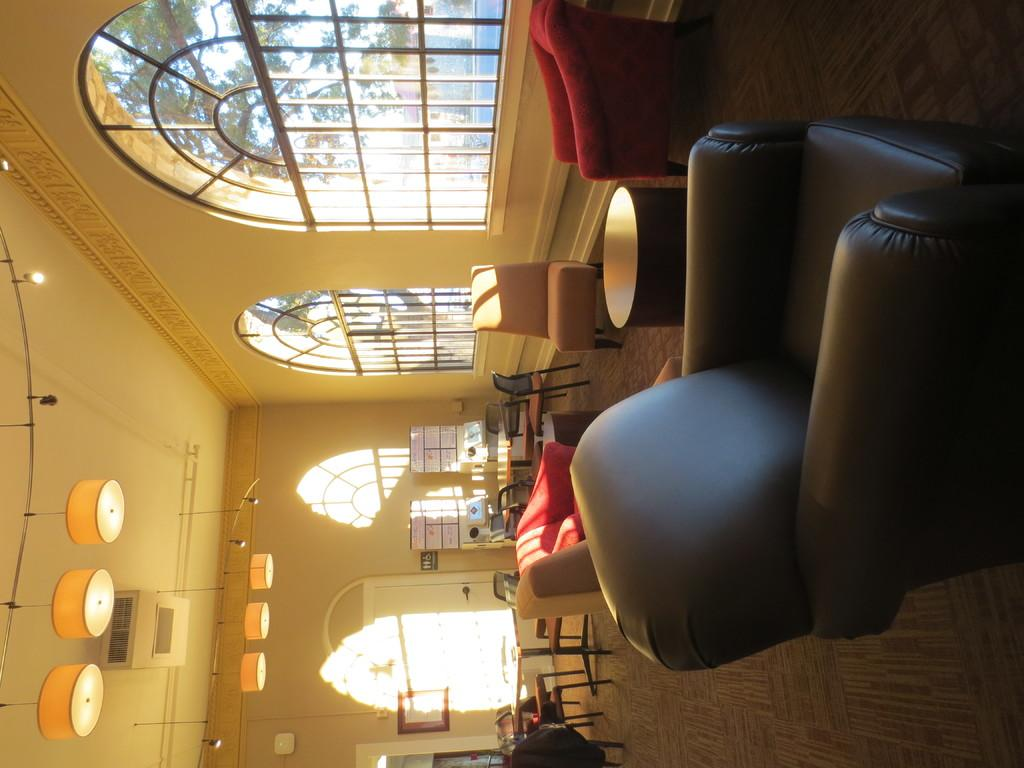What objects are present in the image that provide illumination? There are lights in the image. What type of furniture can be seen in the image? There are chairs, tables, and sofa chairs in the image. What architectural feature is present on the wall in the image? There is a frame on the wall in the image. How can one enter or exit the space depicted in the image? There is a door in the image. What material is present in the image that can be used for writing or displaying information? There are boards in the image. What allows natural light to enter the space depicted in the image? There are windows in the image. What type of vegetation is visible in the image? There are trees in the image. What type of fowl can be seen roaming around the room in the image? There are no fowl present in the image; it depicts a room with various objects and features. What is the condition of the camp in the image? There is no camp present in the image; it depicts a room with various objects and features. 